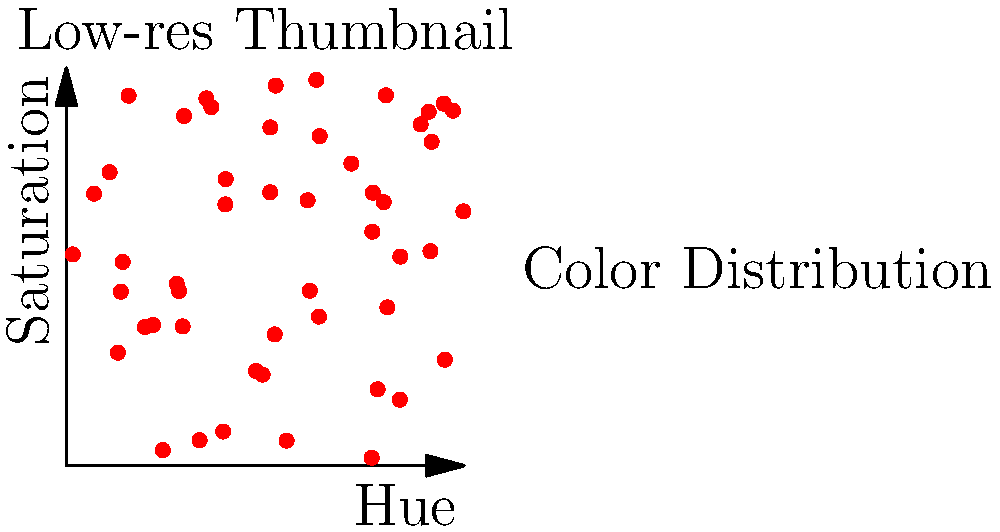As a talented painter, you're experimenting with a machine learning model to predict the dominant color palette in your paintings from low-resolution thumbnails. The scatter plot shows the distribution of color points in the Hue-Saturation space for a thumbnail. Which clustering algorithm would be most suitable for identifying the main color groups, considering the non-uniform distribution and potential overlapping clusters? To determine the most suitable clustering algorithm for identifying the main color groups in this scenario, we need to consider the following factors:

1. Non-uniform distribution: The scatter plot shows that the color points are not evenly distributed in the Hue-Saturation space.

2. Potential overlapping clusters: There may be areas where color groups are close together or overlapping.

3. Unknown number of clusters: The number of dominant colors in a painting is not known beforehand.

4. Flexibility in cluster shape: Color clusters may not always be perfectly circular or have a specific shape.

Considering these factors, we can evaluate some common clustering algorithms:

a) K-means: While popular, it assumes spherical clusters and requires specifying the number of clusters beforehand, which may not be ideal for this scenario.

b) Hierarchical clustering: Can work with different cluster shapes but may be computationally expensive for large datasets.

c) DBSCAN (Density-Based Spatial Clustering of Applications with Noise): Can handle non-uniform distributions and doesn't require specifying the number of clusters, but may struggle with varying densities.

d) Gaussian Mixture Models (GMM): Can handle overlapping clusters and provide probabilistic assignments, but assumes Gaussian distributions.

e) Mean Shift: Can handle non-uniform distributions and doesn't require specifying the number of clusters, but may be computationally expensive.

Given the requirements, the most suitable algorithm for this task would be DBSCAN or Mean Shift. However, DBSCAN is generally more efficient and can handle varying cluster densities better, making it the optimal choice for identifying the main color groups in this scenario.
Answer: DBSCAN 